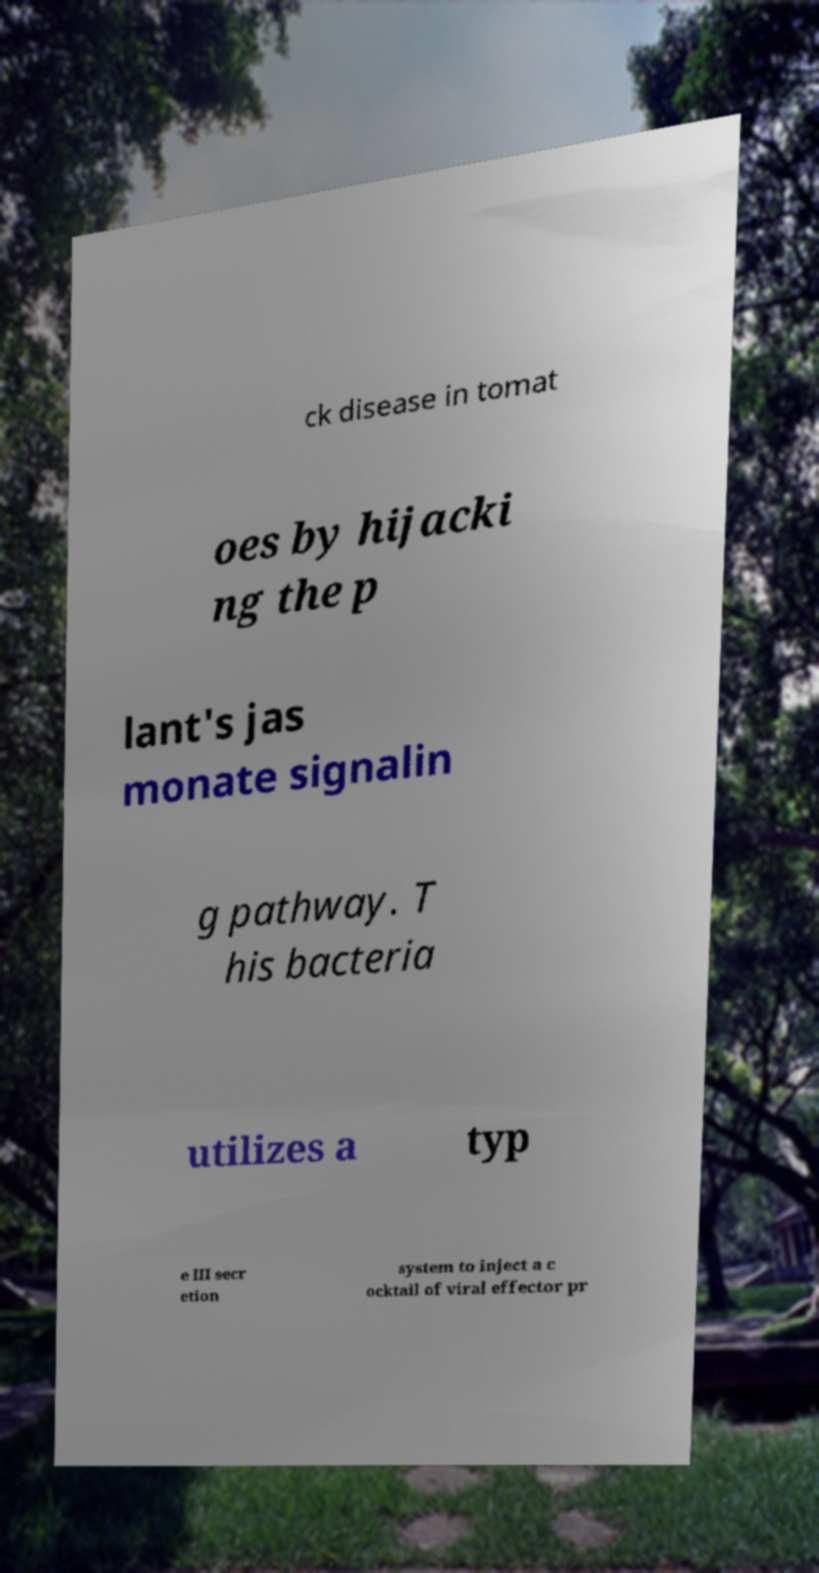Please read and relay the text visible in this image. What does it say? ck disease in tomat oes by hijacki ng the p lant's jas monate signalin g pathway. T his bacteria utilizes a typ e III secr etion system to inject a c ocktail of viral effector pr 